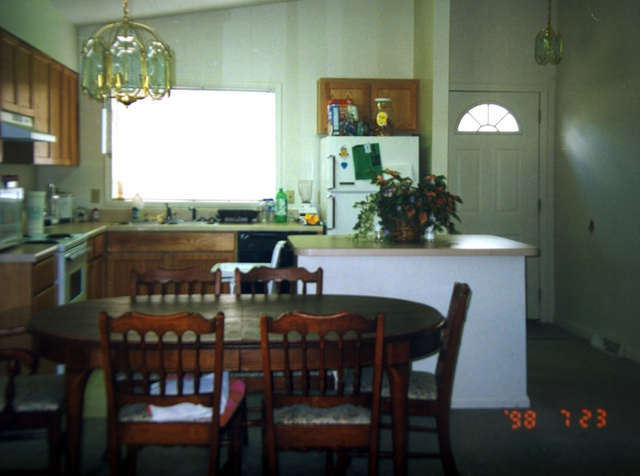Describe the objects in this image and their specific colors. I can see chair in darkgreen, black, maroon, gray, and darkgray tones, chair in darkgreen, black, maroon, and gray tones, dining table in darkgreen, black, and gray tones, refrigerator in darkgreen, lightblue, beige, and darkgray tones, and potted plant in darkgreen and black tones in this image. 